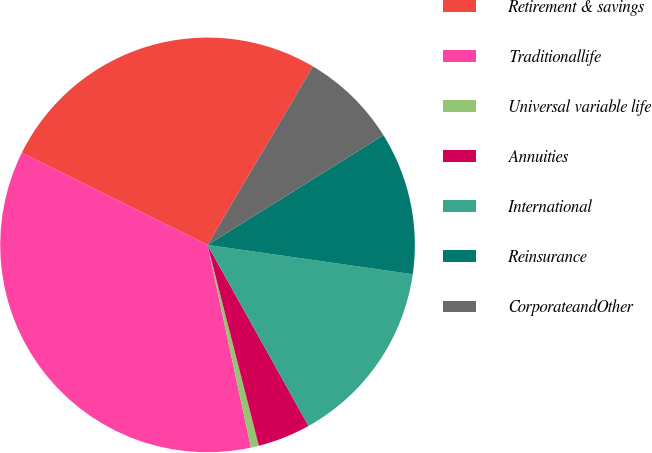Convert chart. <chart><loc_0><loc_0><loc_500><loc_500><pie_chart><fcel>Retirement & savings<fcel>Traditionallife<fcel>Universal variable life<fcel>Annuities<fcel>International<fcel>Reinsurance<fcel>CorporateandOther<nl><fcel>26.16%<fcel>35.69%<fcel>0.62%<fcel>4.12%<fcel>14.64%<fcel>11.14%<fcel>7.63%<nl></chart> 